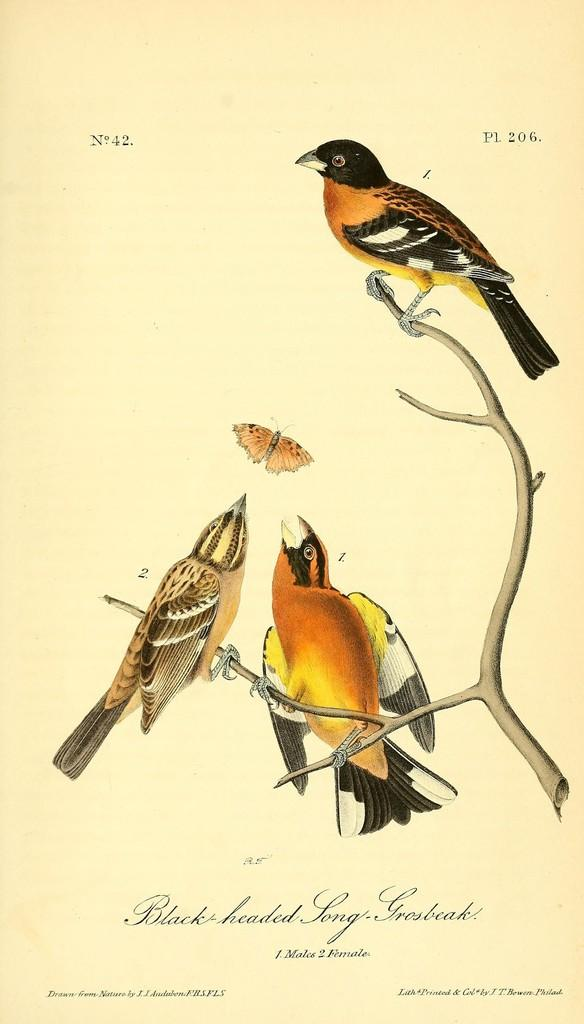What animals can be seen in the image? There are birds on a branch in the image. What other creature is present in the image? There is a butterfly in the image. What is written or displayed at the bottom of the image? There is text at the bottom of the image. What numbers can be found in the image? There are numbers in the top left and right corners of the image. What type of toothbrush is being used by the birds in the image? There is no toothbrush present in the image; it features birds on a branch and a butterfly. Where is the meeting taking place in the image? There is no meeting depicted in the image; it only shows birds, a butterfly, text, and numbers. 